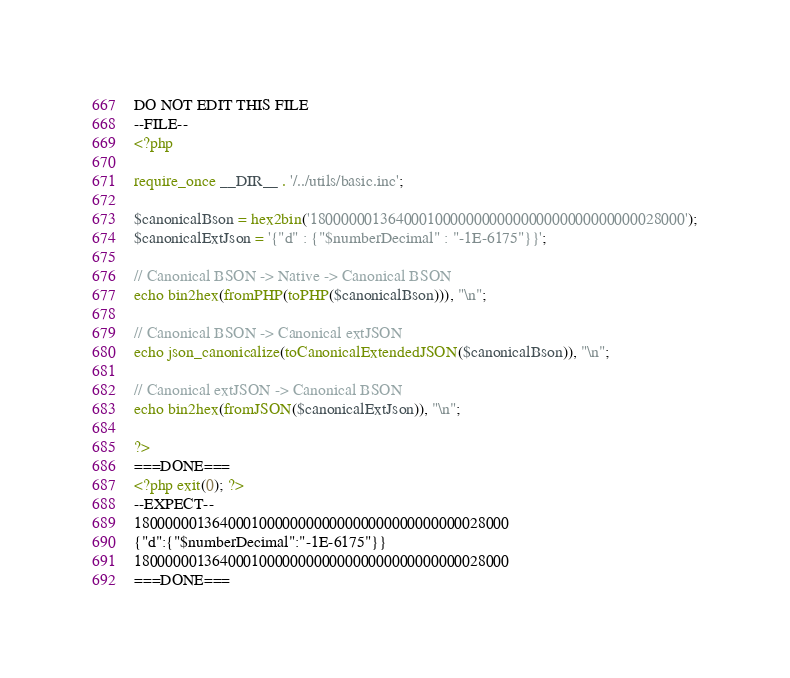Convert code to text. <code><loc_0><loc_0><loc_500><loc_500><_PHP_>DO NOT EDIT THIS FILE
--FILE--
<?php

require_once __DIR__ . '/../utils/basic.inc';

$canonicalBson = hex2bin('180000001364000100000000000000000000000000028000');
$canonicalExtJson = '{"d" : {"$numberDecimal" : "-1E-6175"}}';

// Canonical BSON -> Native -> Canonical BSON
echo bin2hex(fromPHP(toPHP($canonicalBson))), "\n";

// Canonical BSON -> Canonical extJSON
echo json_canonicalize(toCanonicalExtendedJSON($canonicalBson)), "\n";

// Canonical extJSON -> Canonical BSON
echo bin2hex(fromJSON($canonicalExtJson)), "\n";

?>
===DONE===
<?php exit(0); ?>
--EXPECT--
180000001364000100000000000000000000000000028000
{"d":{"$numberDecimal":"-1E-6175"}}
180000001364000100000000000000000000000000028000
===DONE===</code> 